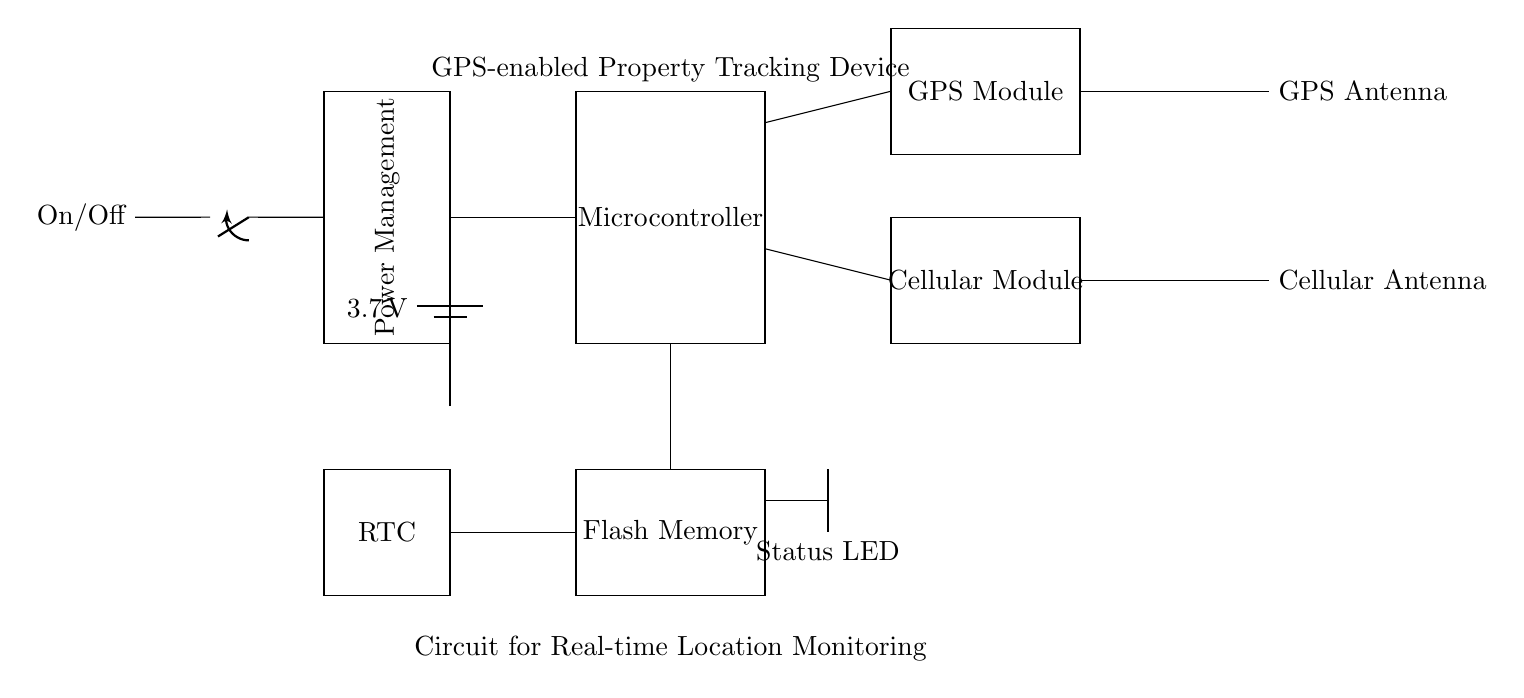What is the voltage of the power supply? The circuit shows a battery labeled with a voltage of 3.7 volts, indicating the power supply's voltage.
Answer: 3.7 volts What components are present in the circuit? By examining the circuit, the components visible include a microcontroller, GPS module, cellular module, antennas, power management, flash memory, status LED, and real-time clock.
Answer: Microcontroller, GPS module, cellular module, antennas, power management, flash memory, status LED, real-time clock What is the purpose of the antennas? The antennas in the circuit are labeled as GPS Antenna and Cellular Antenna, indicating their functions to receive GPS signals and cellular data, respectively.
Answer: GPS and Cellular signals How are the GPS module and cellular module connected to the microcontroller? The GPS module is connected to the microcontroller through a line connecting points 5 and 7, while the cellular module connects at points 5 and 2, showing a shared connection with the microcontroller.
Answer: Through the microcontroller What is the function of the power management block? The power management block regulates the power supply to the circuit, ensuring proper distribution and possibly includes an on/off switch for power control.
Answer: Regulates power supply How does the status LED indicate the device's status? The status LED is connected to the circuit via a line and is likely illuminated when the device is powered on, providing a visual indicator of operational status based on its connection.
Answer: Visual operational status What type of memory is used in this circuit? The circuit contains a component labeled as Flash Memory, which is a type of non-volatile storage used for retaining data even when power is off.
Answer: Flash Memory 